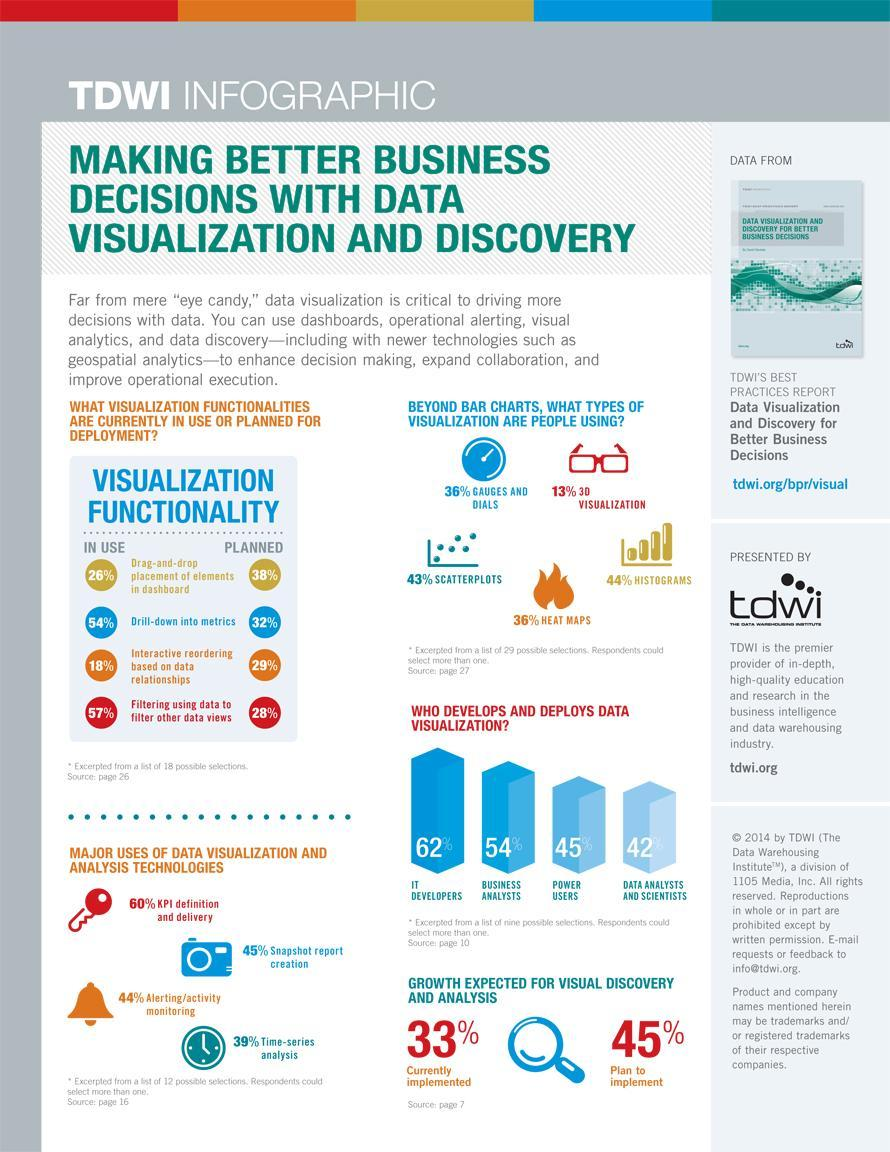What percentage of people are not using gauges and dials as data visualization?
Answer the question with a short phrase. 64% What percentage of people are not using histograms as data visualization? 56% What percentage of people are not using 3D visualization as data visualization? 87% How many uses of data visualization and analysis technologies are mentioned in this infographic?? 4 What percentage of people are not using scatterplots as data visualization? 57% What percentage of people are not using heat maps as data visualization? 64% 